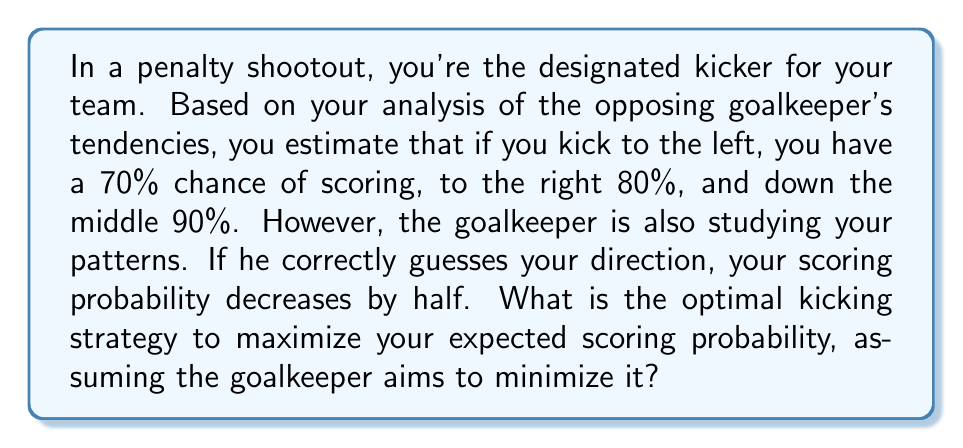Give your solution to this math problem. To solve this problem, we'll use game theory, specifically the concept of mixed strategy Nash equilibrium.

1) First, let's define our payoff matrix. The rows represent your choices, and the columns represent the goalkeeper's choices:

   $$ \begin{array}{c|ccc}
      & \text{Left} & \text{Right} & \text{Middle} \\
      \hline
      \text{Left} & 0.35 & 0.7 & 0.7 \\
      \text{Right} & 0.8 & 0.4 & 0.8 \\
      \text{Middle} & 0.9 & 0.9 & 0.45
   \end{array} $$

2) Let $x$, $y$, and $z$ be the probabilities of kicking left, right, and middle respectively. We know that $x + y + z = 1$.

3) For the goalkeeper, let $p$, $q$, and $r$ be the probabilities of diving left, right, and staying in the middle respectively.

4) For a mixed strategy equilibrium, the expected payoff for each of your pure strategies should be equal:

   $0.35p + 0.7q + 0.7r = 0.8p + 0.4q + 0.8r = 0.9p + 0.9q + 0.45r$

5) From these equations:

   $0.35p + 0.7q + 0.7r = 0.8p + 0.4q + 0.8r$
   $0.45p - 0.3q + 0.1r = 0$

   $0.35p + 0.7q + 0.7r = 0.9p + 0.9q + 0.45r$
   $0.55p + 0.2q - 0.25r = 0$

6) Solving these equations along with $p + q + r = 1$, we get:
   
   $p = \frac{11}{31}, q = \frac{14}{31}, r = \frac{6}{31}$

7) Substituting these values back into any of the equalities from step 4, we can find the expected payoff, which is approximately 0.6774.

8) To find your optimal strategy, we use the same principle for the goalkeeper's perspective:

   $0.35x + 0.8y + 0.9z = 0.7x + 0.4y + 0.9z = 0.7x + 0.8y + 0.45z$

9) Solving these equations along with $x + y + z = 1$, we get:

   $x = \frac{14}{31}, y = \frac{11}{31}, z = \frac{6}{31}$

Therefore, your optimal strategy is to kick left with probability $\frac{14}{31}$, right with probability $\frac{11}{31}$, and middle with probability $\frac{6}{31}$.
Answer: The optimal kicking strategy is to kick left with probability $\frac{14}{31}$ (approximately 45.16%), right with probability $\frac{11}{31}$ (approximately 35.48%), and middle with probability $\frac{6}{31}$ (approximately 19.35%). 